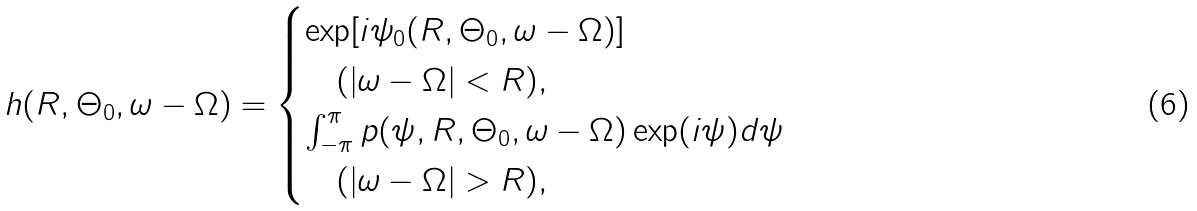<formula> <loc_0><loc_0><loc_500><loc_500>h ( R , \Theta _ { 0 } , \omega - \Omega ) = \begin{cases} \exp [ i \psi _ { 0 } ( R , \Theta _ { 0 } , \omega - \Omega ) ] \\ \quad ( | \omega - \Omega | < R ) , \\ \int _ { - \pi } ^ { \pi } p ( \psi , R , \Theta _ { 0 } , \omega - \Omega ) \exp ( i \psi ) d \psi \\ \quad ( | \omega - \Omega | > R ) , \end{cases}</formula> 